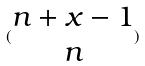Convert formula to latex. <formula><loc_0><loc_0><loc_500><loc_500>( \begin{matrix} n + x - 1 \\ n \end{matrix} )</formula> 